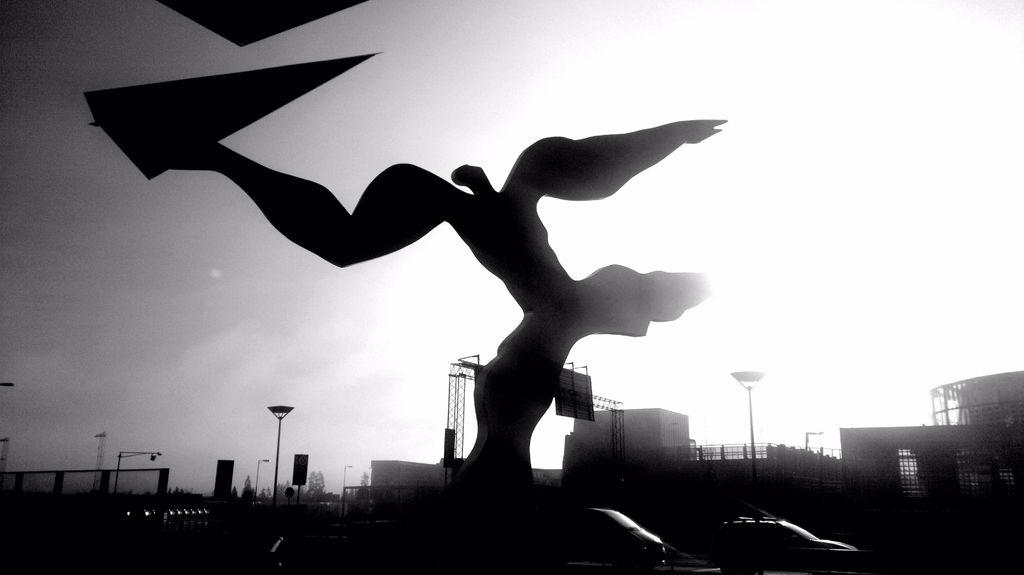What is the color scheme of the image? The image is black and white. What is the main subject in the image? There is a sculpture in the image. What other objects can be seen in the image? There is a pole, a fence, a door, trees, vehicles, and a building in the image. What is visible in the background of the image? The sky is visible in the image. How does the existence of sand affect the sculpture in the image? There is no sand present in the image, so its existence does not affect the sculpture. What type of arch can be seen in the image? There is no arch present in the image. 